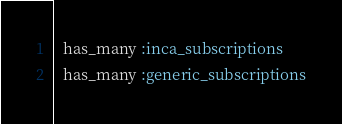<code> <loc_0><loc_0><loc_500><loc_500><_Ruby_>  has_many :inca_subscriptions
  has_many :generic_subscriptions
</code> 